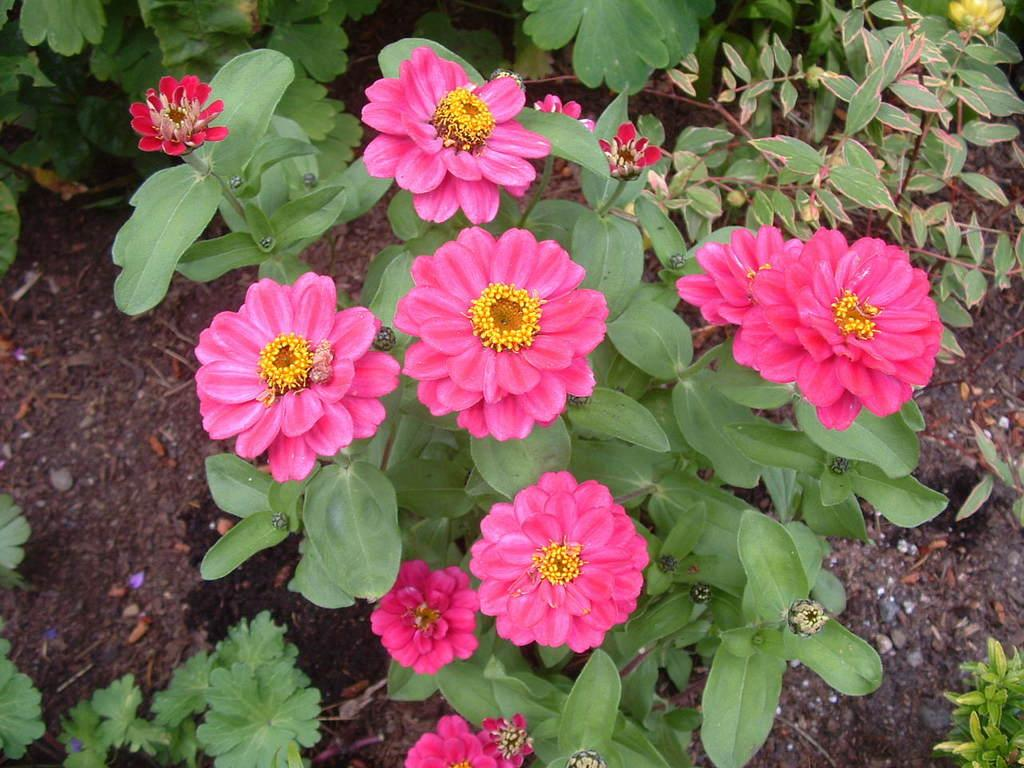What types of living organisms can be seen in the image? The image contains plants and flowers. Can you describe the environment in which the plants and flowers are located? There is soil visible in the background of the image. What type of cave can be seen in the background of the image? There is no cave present in the image; it features plants and flowers with soil in the background. 